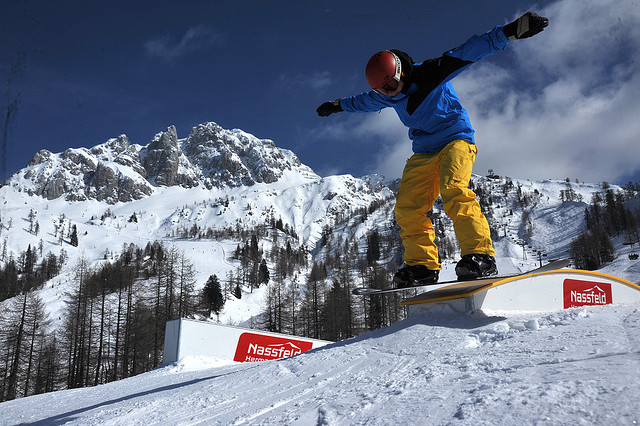Please extract the text content from this image. Nassfeld Nassfeld 